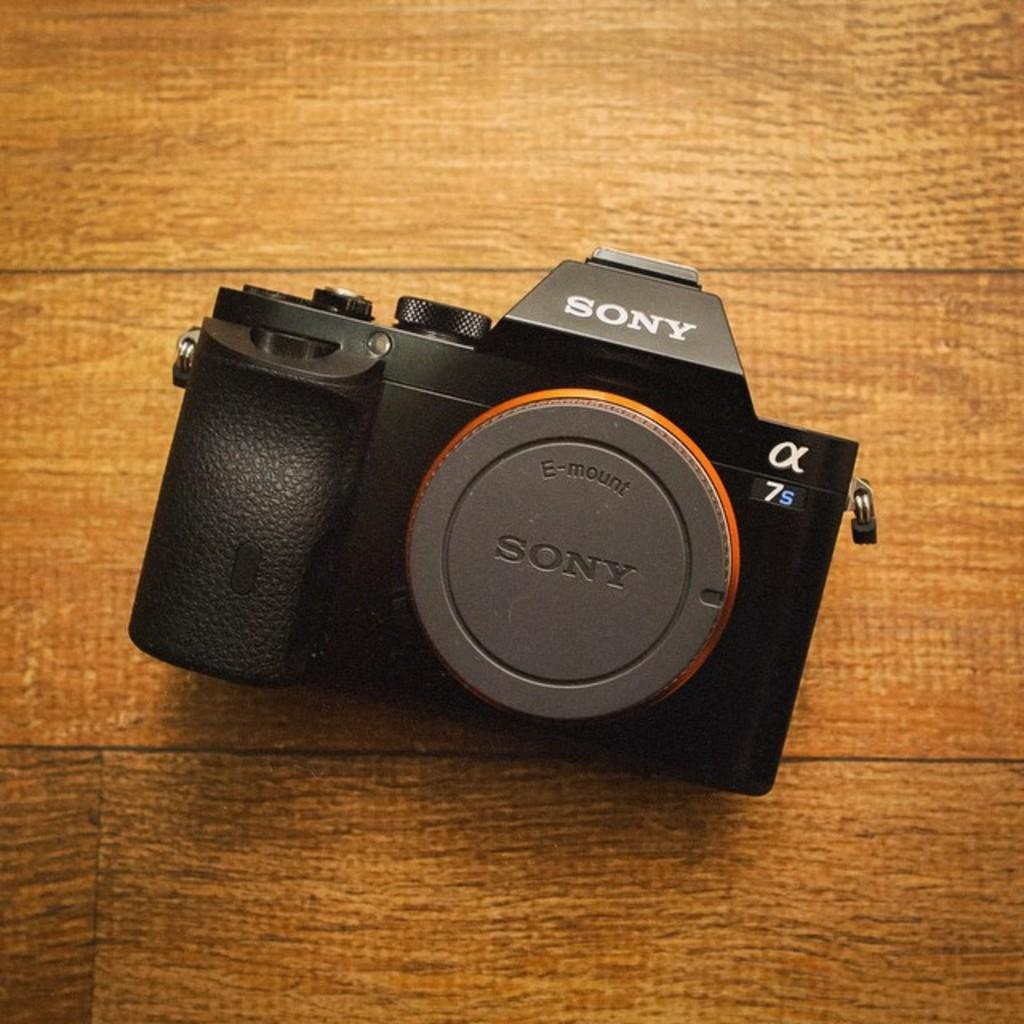Provide a one-sentence caption for the provided image. An antique Sony Camera, model number 7s is sitting on a wooden floor. 